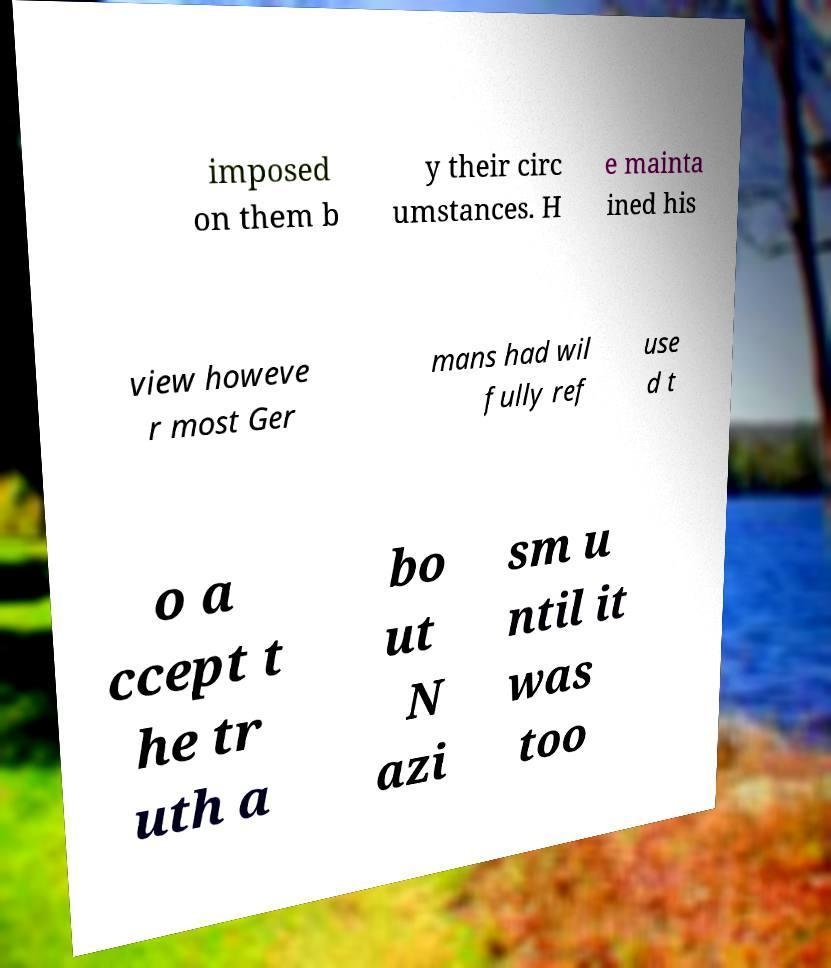What messages or text are displayed in this image? I need them in a readable, typed format. imposed on them b y their circ umstances. H e mainta ined his view howeve r most Ger mans had wil fully ref use d t o a ccept t he tr uth a bo ut N azi sm u ntil it was too 